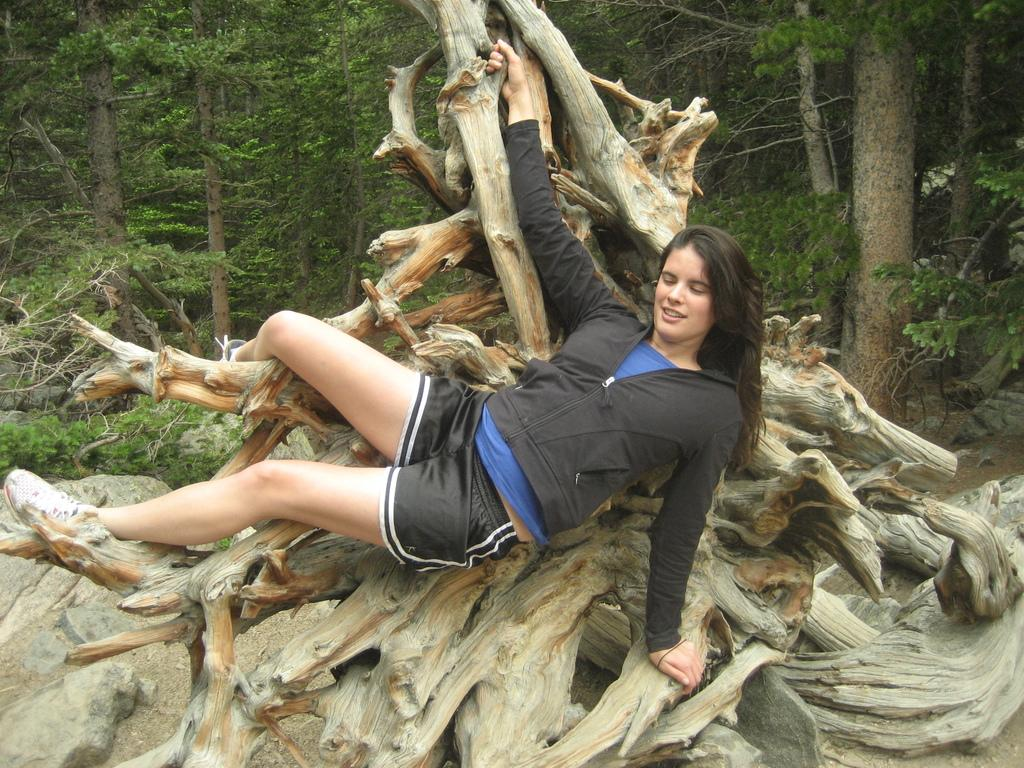What is the lady doing in the image? The lady is lying on the trunk in the image. What type of natural elements can be seen in the image? There are plants, rocks, and trees in the image. What month is it in the image? The month cannot be determined from the image, as there is no information about the time of year. 